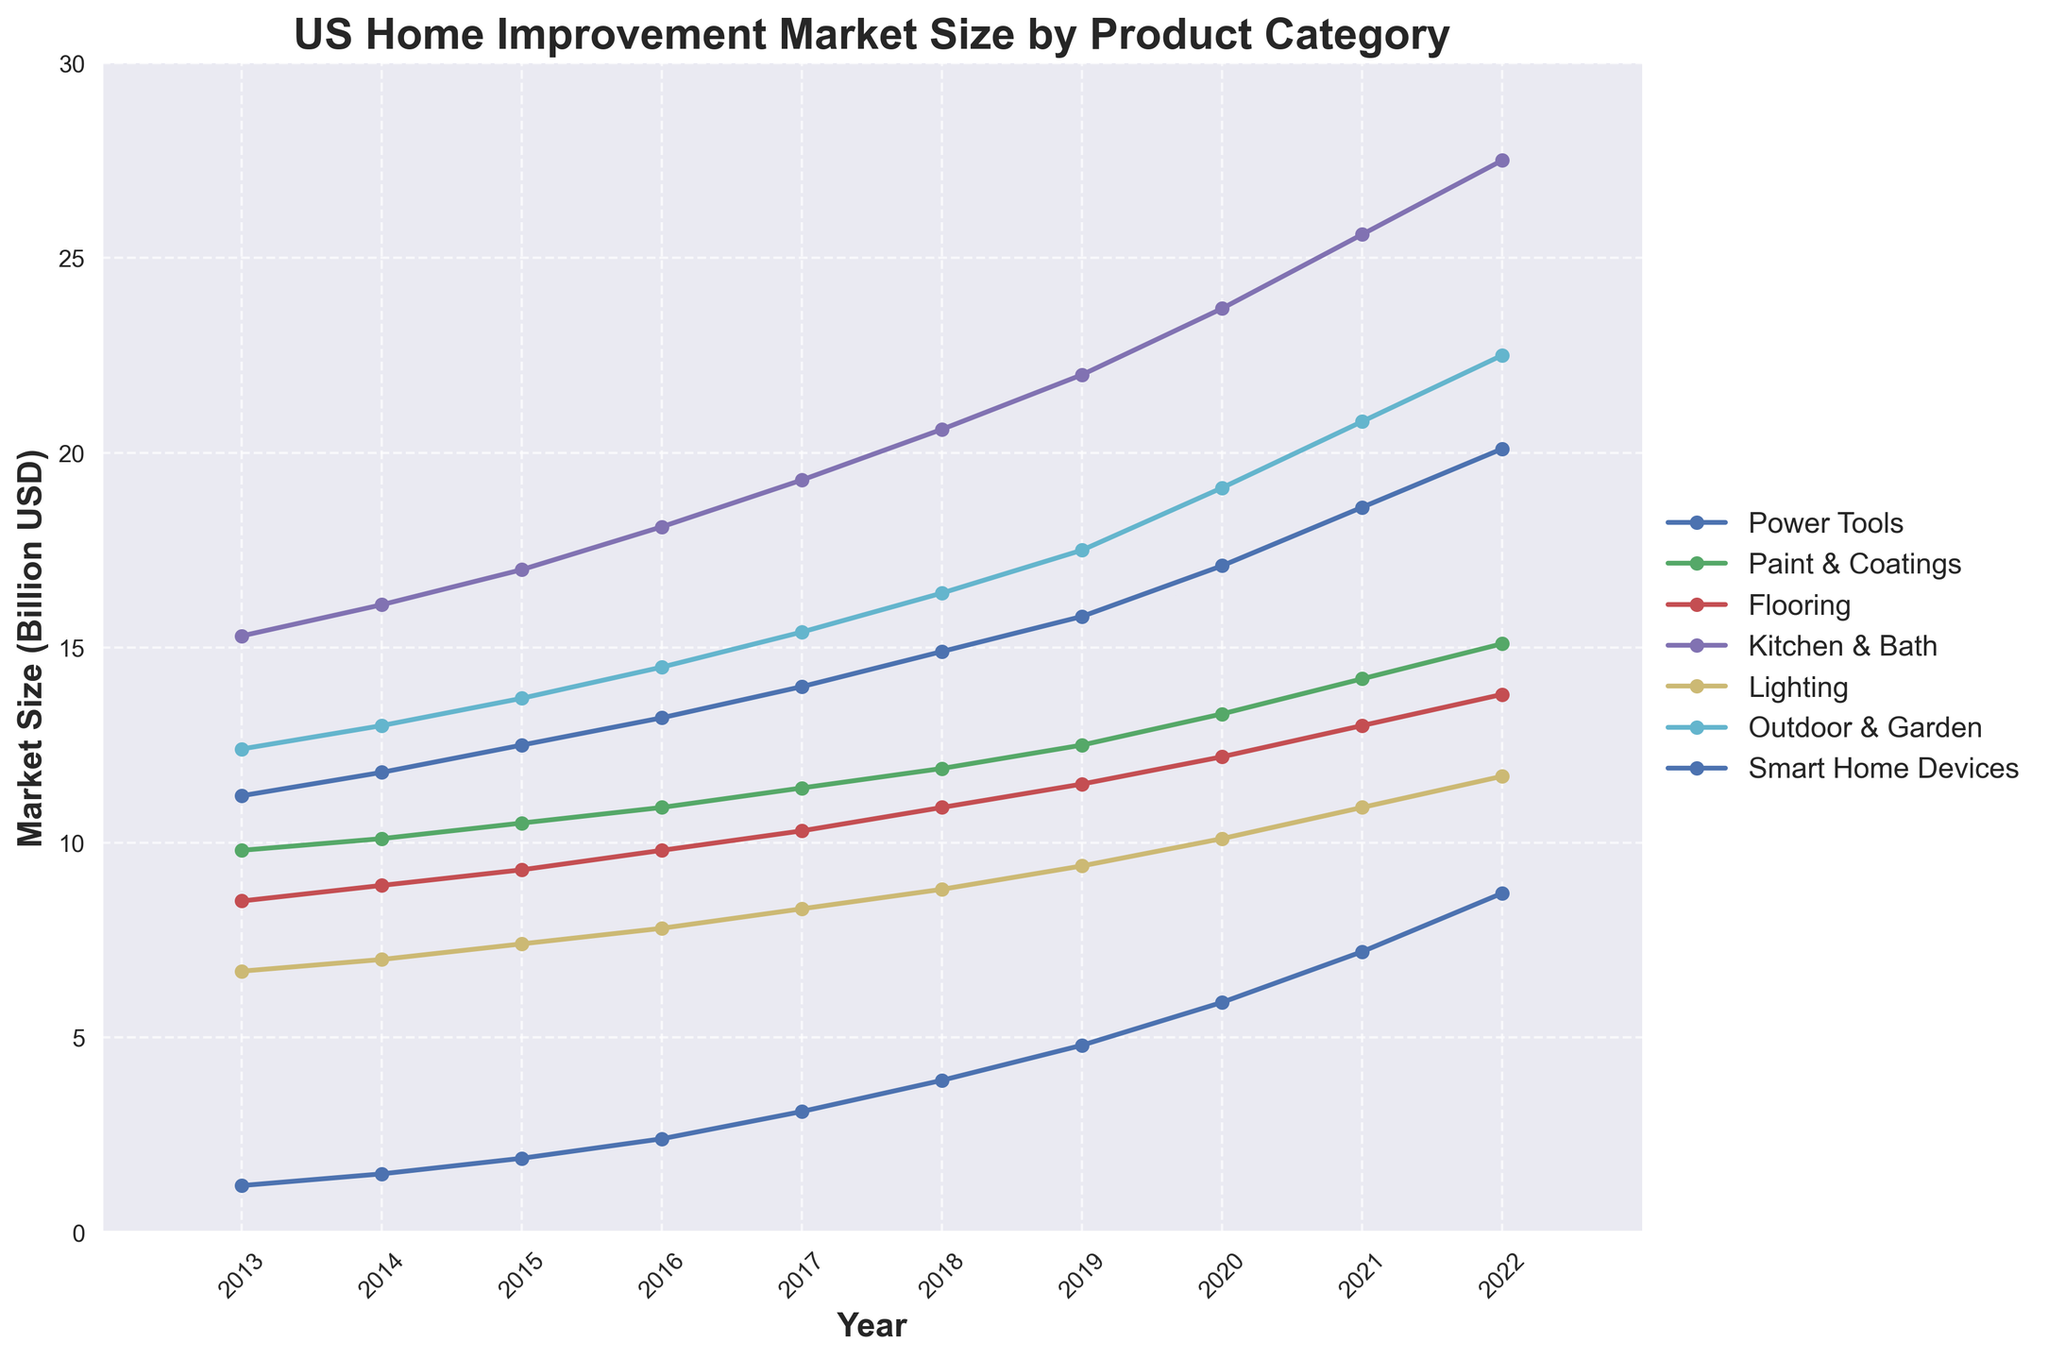What year saw the highest market size for Smart Home Devices? The line representing Smart Home Devices peaks at the rightmost point on the graph, which aligns with the year 2022.
Answer: 2022 Which product category has shown the most consistent annual growth? Observing the slope of the lines, the Kitchen & Bath category has the smoothest upward trajectory with no dips or stagnant phases across the years from 2013 to 2022.
Answer: Kitchen & Bath Compare the market size for Power Tools in 2014 and 2019. Which year had a greater market size and by how much? From the plot, the Power Tools category had a value of 11.8 billion USD in 2014 and 15.8 billion USD in 2019. The difference is calculated as 15.8 - 11.8 = 4 billion USD.
Answer: 2019, by 4 billion USD What product category had a market size closest to 10 billion USD in 2018? Evaluating the lines’ intersection with the 10 billion USD mark in 2018, the Flooring category is very close with a value of 10.9 billion USD.
Answer: Flooring What is the combined market size of Paint & Coatings and Lighting in 2015? The market size for Paint & Coatings in 2015 is 10.5 billion USD, and for Lighting, it is 7.4 billion USD. Summing them up gives 10.5 + 7.4 = 17.9 billion USD.
Answer: 17.9 billion USD Between which consecutive years did the market size for Outdoor & Garden increase the most? The steepest slope in the Outdoor & Garden line occurs between 2019 and 2020, rising from 17.5 billion USD to 19.1 billion USD, an increase of 1.6 billion USD.
Answer: 2019 to 2020 Which product category had the largest absolute increase in market size from 2013 to 2022? The difference in market size from 2013 to 2022 for each category is calculated: 
- Power Tools: 20.1 - 11.2 = 8.9 billion USD
- Paint & Coatings: 15.1 - 9.8 = 5.3 billion USD
- Flooring: 13.8 - 8.5 = 5.3 billion USD
- Kitchen & Bath: 27.5 - 15.3 = 12.2 billion USD
- Lighting: 11.7 - 6.7 = 5 billion USD
- Outdoor & Garden: 22.5 - 12.4 = 10.1 billion USD 
- Smart Home Devices: 8.7 - 1.2 = 7.5 billion USD
The Kitchen & Bath category has the largest absolute increase of 12.2 billion USD.
Answer: Kitchen & Bath, by 12.2 billion USD In which year did the market size for Lighting surpass 10 billion USD for the first time? The Lighting category line crosses the 10 billion USD mark in the graph, occurring in the year 2021.
Answer: 2021 